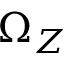Convert formula to latex. <formula><loc_0><loc_0><loc_500><loc_500>\Omega _ { Z }</formula> 